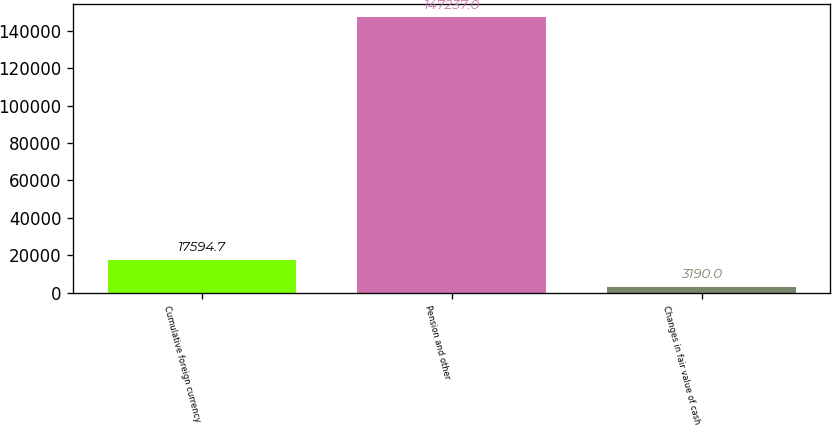Convert chart. <chart><loc_0><loc_0><loc_500><loc_500><bar_chart><fcel>Cumulative foreign currency<fcel>Pension and other<fcel>Changes in fair value of cash<nl><fcel>17594.7<fcel>147237<fcel>3190<nl></chart> 